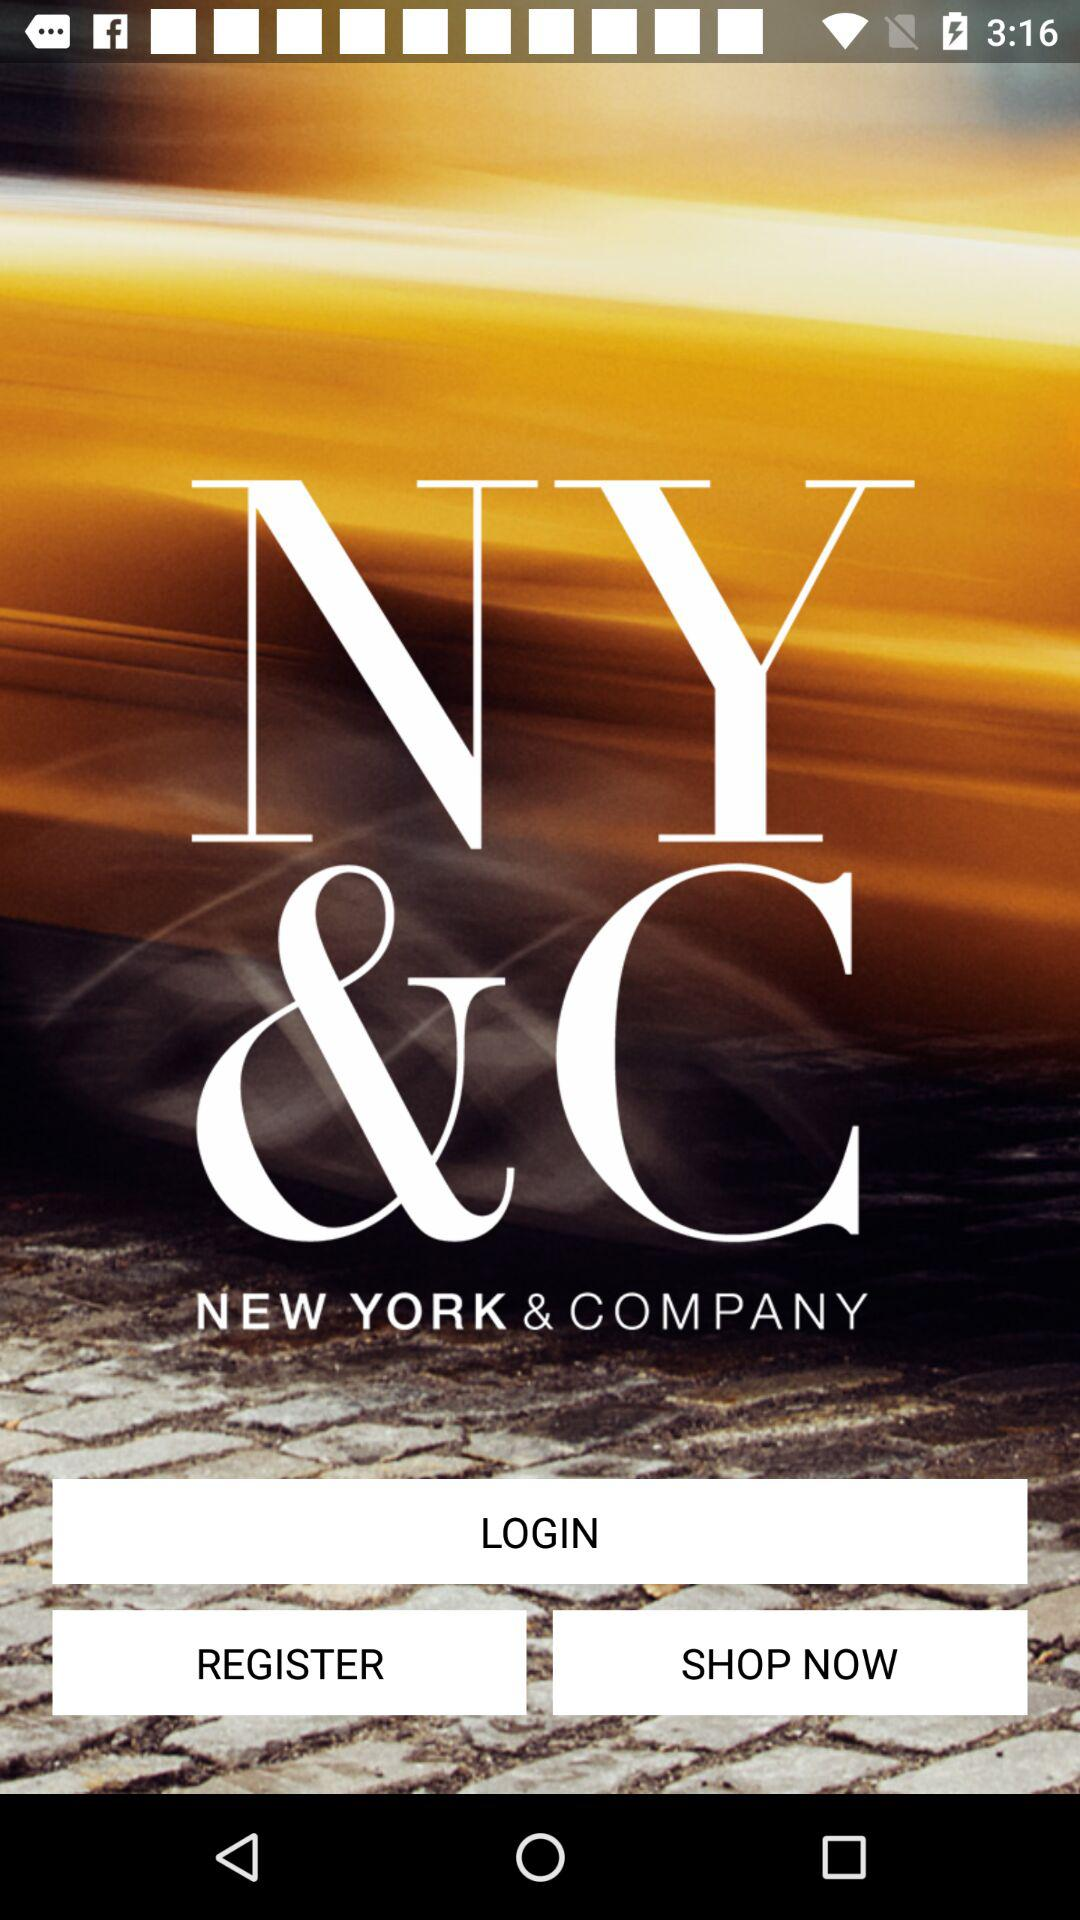What is the application name? The application name is "NY & COMPANY". 